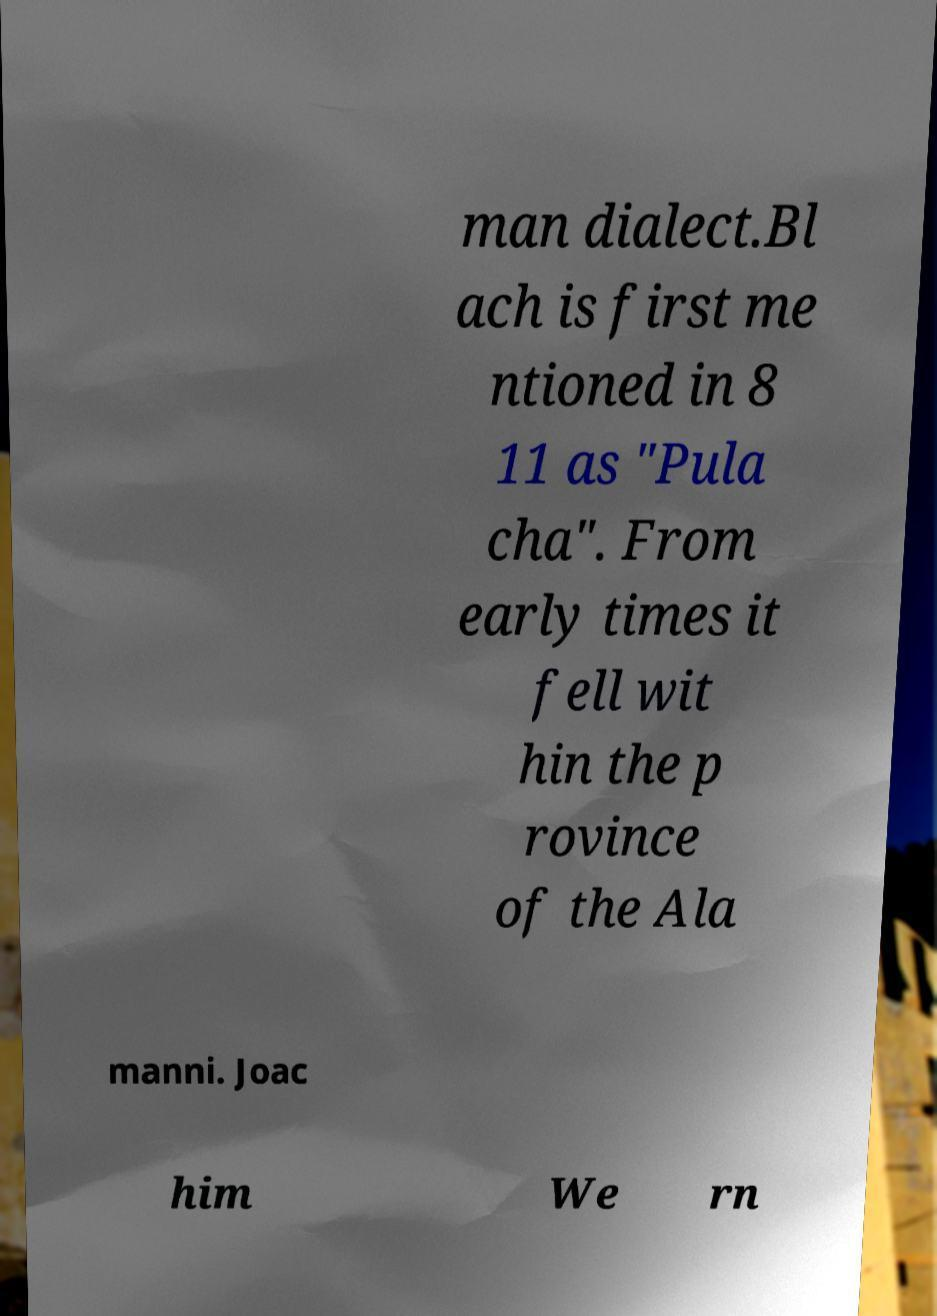Could you extract and type out the text from this image? man dialect.Bl ach is first me ntioned in 8 11 as "Pula cha". From early times it fell wit hin the p rovince of the Ala manni. Joac him We rn 